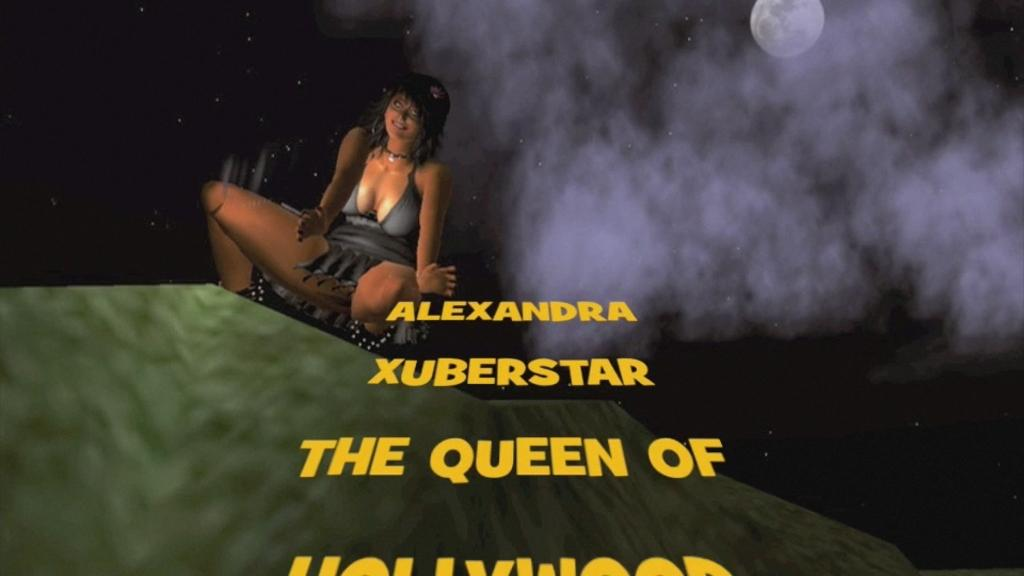What type of image is being described? The image is animated. Can you describe the lady in the image? There is a lady sitting in the image. What celestial body can be seen in the sky in the image? There is a moon visible in the sky. What additional information is provided at the bottom of the image? There is text written at the bottom of the image. What type of wilderness can be seen in the image? There is no wilderness present in the image; it is an animated scene with a lady sitting and a moon visible in the sky. 